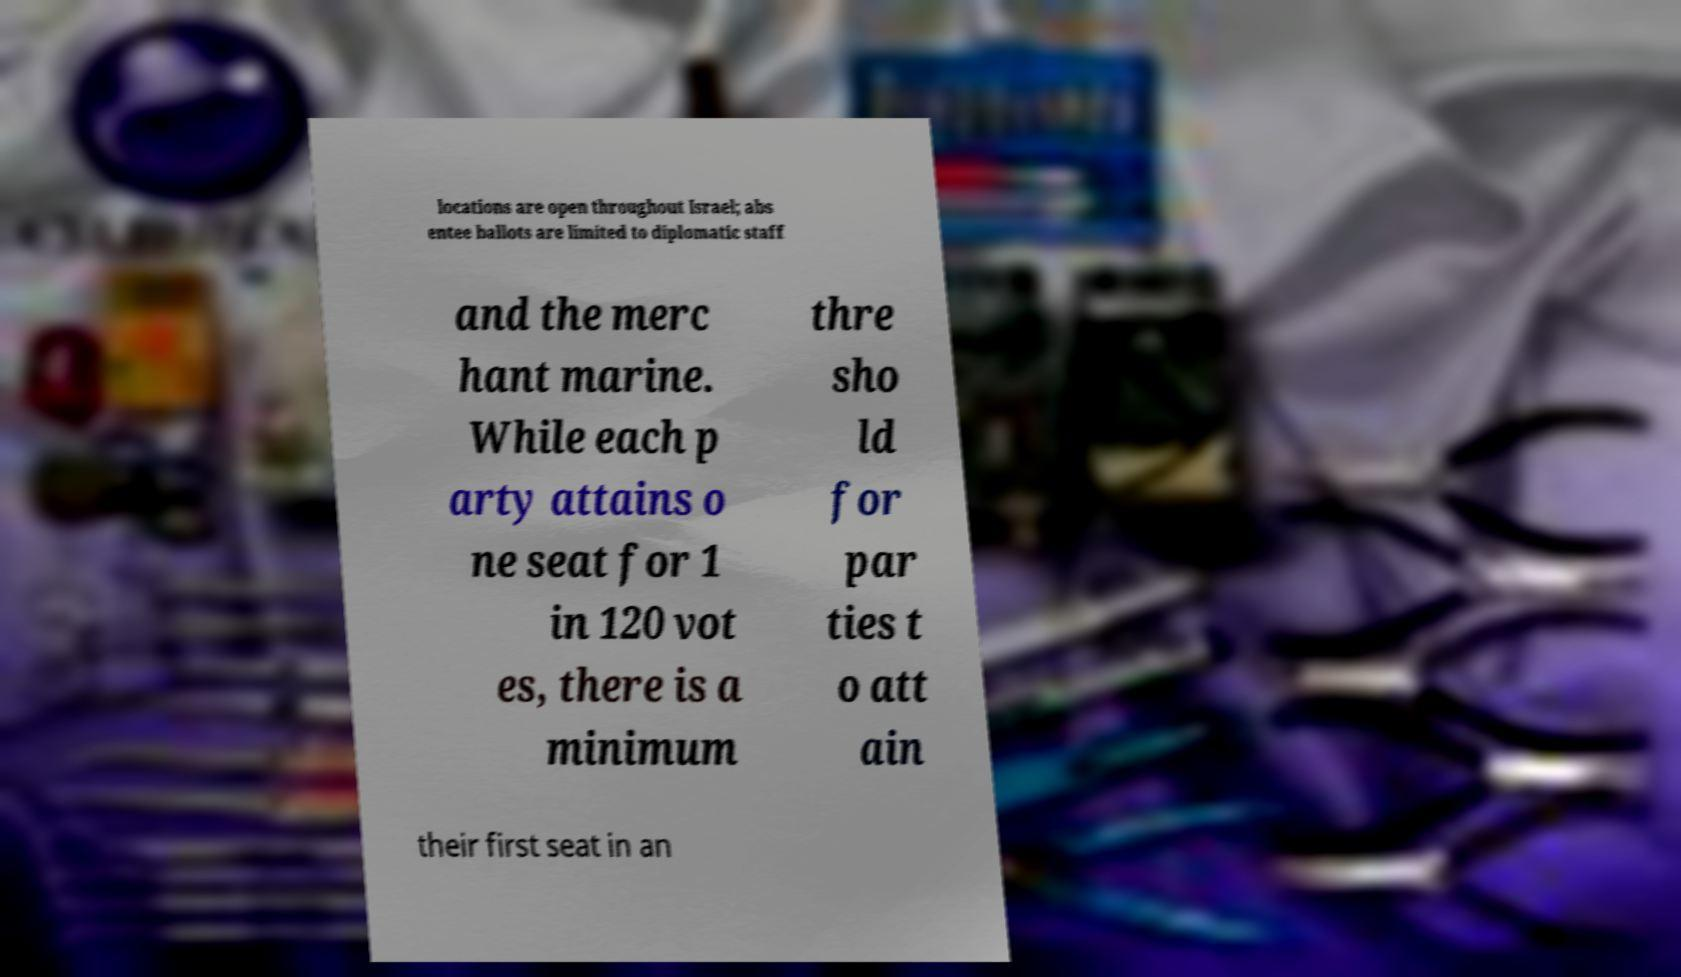Could you assist in decoding the text presented in this image and type it out clearly? locations are open throughout Israel; abs entee ballots are limited to diplomatic staff and the merc hant marine. While each p arty attains o ne seat for 1 in 120 vot es, there is a minimum thre sho ld for par ties t o att ain their first seat in an 